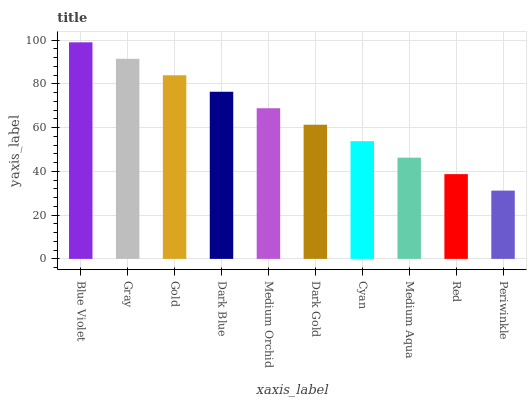Is Gray the minimum?
Answer yes or no. No. Is Gray the maximum?
Answer yes or no. No. Is Blue Violet greater than Gray?
Answer yes or no. Yes. Is Gray less than Blue Violet?
Answer yes or no. Yes. Is Gray greater than Blue Violet?
Answer yes or no. No. Is Blue Violet less than Gray?
Answer yes or no. No. Is Medium Orchid the high median?
Answer yes or no. Yes. Is Dark Gold the low median?
Answer yes or no. Yes. Is Periwinkle the high median?
Answer yes or no. No. Is Dark Blue the low median?
Answer yes or no. No. 